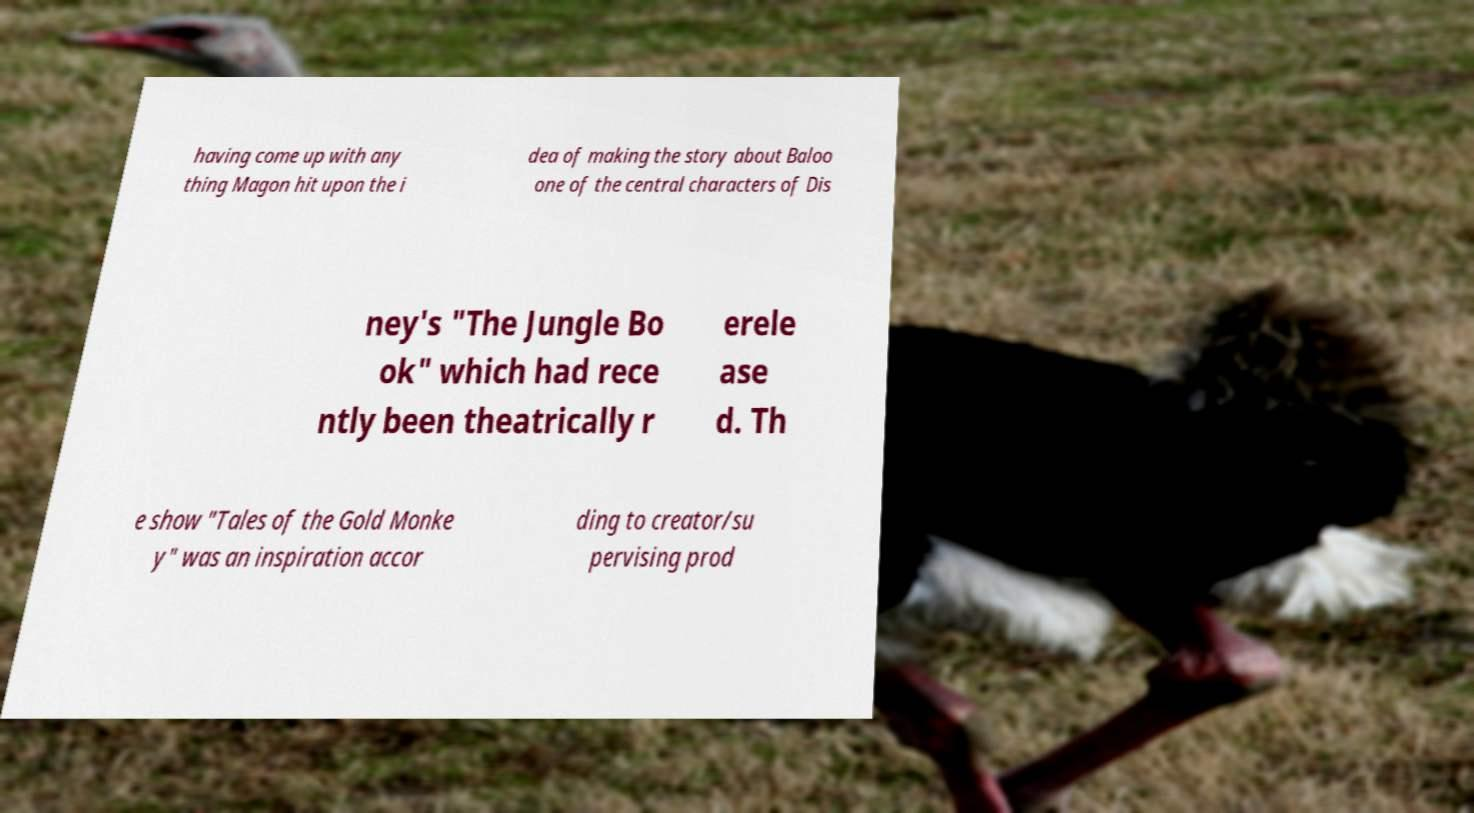Can you read and provide the text displayed in the image?This photo seems to have some interesting text. Can you extract and type it out for me? having come up with any thing Magon hit upon the i dea of making the story about Baloo one of the central characters of Dis ney's "The Jungle Bo ok" which had rece ntly been theatrically r erele ase d. Th e show "Tales of the Gold Monke y" was an inspiration accor ding to creator/su pervising prod 